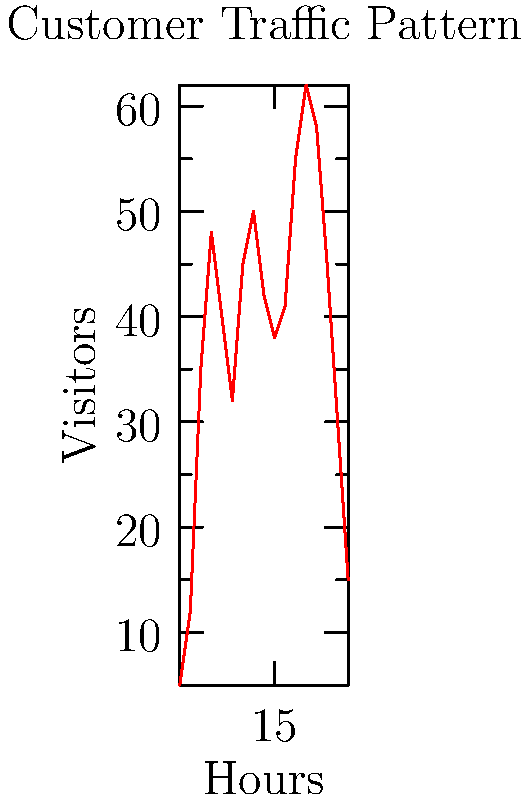Based on the line graph showing hourly visitor data for your café, during which two-hour period do you observe the highest sustained customer traffic? To determine the two-hour period with the highest sustained customer traffic, we need to analyze the graph and follow these steps:

1. Identify peak points on the graph.
2. Look for periods where the visitor count remains consistently high.
3. Compare different two-hour intervals to find the one with the highest overall traffic.

Analyzing the graph:
1. We see peak points at 9:00 (48 visitors), 13:00 (50 visitors), and 18:00 (62 visitors).
2. The period between 17:00 and 19:00 shows consistently high traffic.
3. Comparing two-hour intervals:
   - 8:00-10:00: High initial peak but drops afterwards
   - 12:00-14:00: Consistently high but not the highest
   - 17:00-19:00: Highest peak (62 visitors) and remains high (58 visitors)

The two-hour period from 17:00 to 19:00 (5 PM to 7 PM) shows the highest sustained customer traffic, with 62 visitors at 18:00 and 58 visitors at 19:00.
Answer: 17:00-19:00 (5 PM-7 PM) 